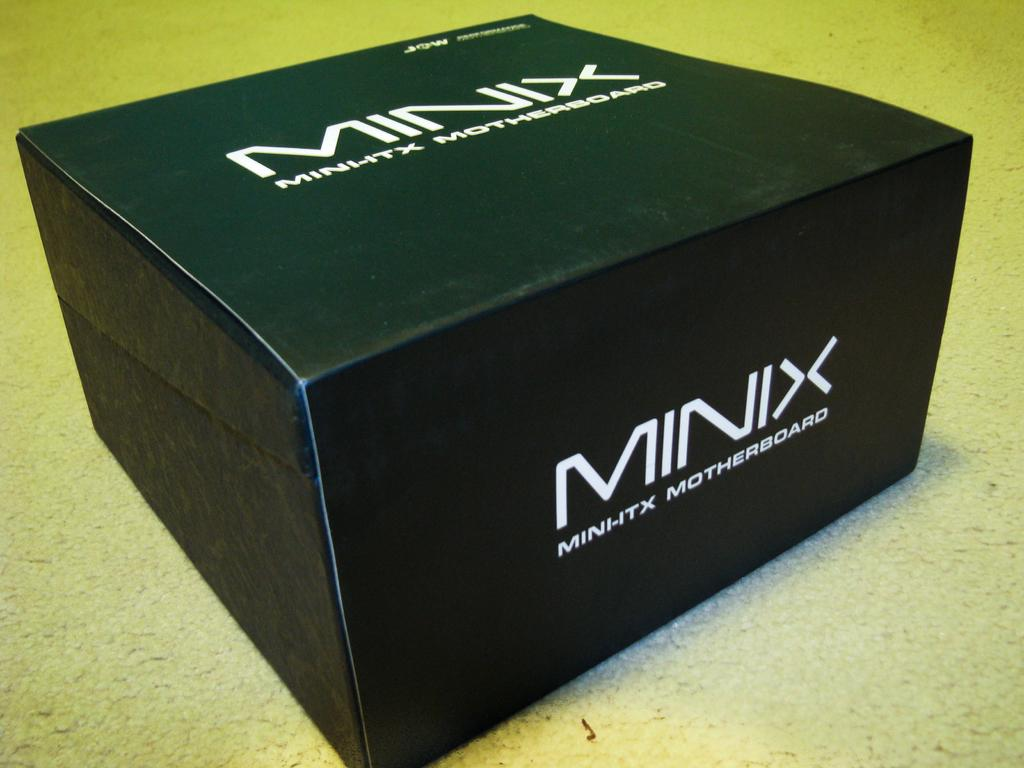<image>
Write a terse but informative summary of the picture. A blackbox contains a Minix Minhtx Motherboard inside 